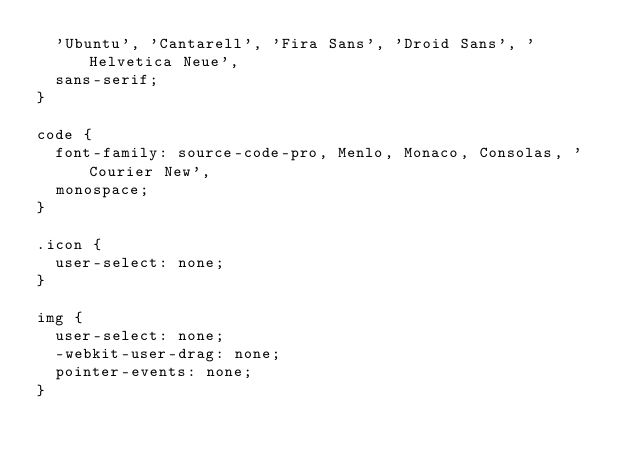Convert code to text. <code><loc_0><loc_0><loc_500><loc_500><_CSS_>  'Ubuntu', 'Cantarell', 'Fira Sans', 'Droid Sans', 'Helvetica Neue',
  sans-serif;
}

code {
  font-family: source-code-pro, Menlo, Monaco, Consolas, 'Courier New',
  monospace;
}

.icon {
  user-select: none;
}

img {
  user-select: none;
  -webkit-user-drag: none;
  pointer-events: none;
}
</code> 